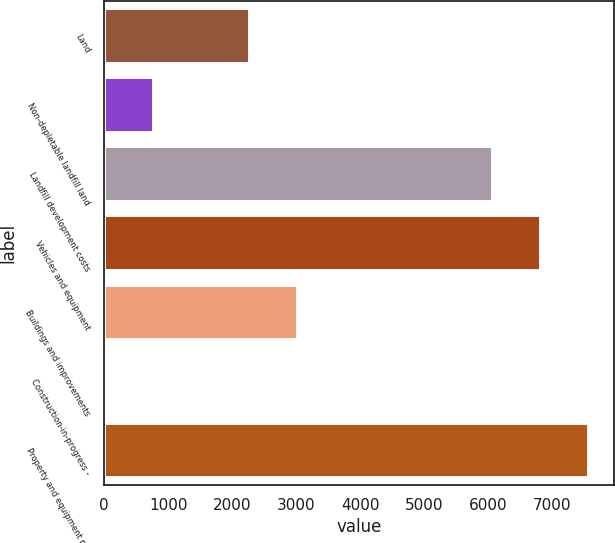<chart> <loc_0><loc_0><loc_500><loc_500><bar_chart><fcel>Land<fcel>Non-depletable landfill land<fcel>Landfill development costs<fcel>Vehicles and equipment<fcel>Buildings and improvements<fcel>Construction-in-progress -<fcel>Property and equipment net<nl><fcel>2283.69<fcel>778.23<fcel>6078.1<fcel>6830.83<fcel>3036.42<fcel>25.5<fcel>7583.56<nl></chart> 